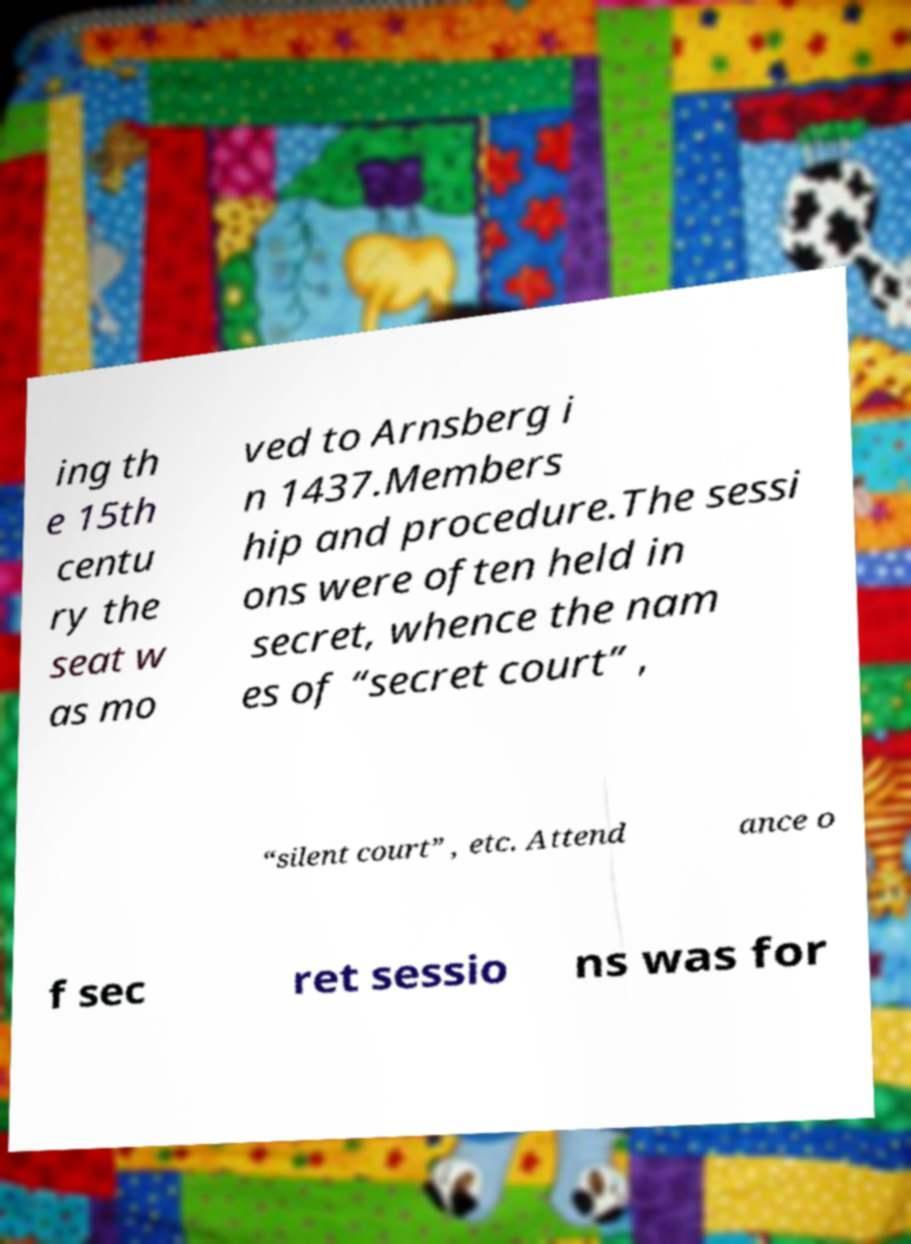Could you extract and type out the text from this image? ing th e 15th centu ry the seat w as mo ved to Arnsberg i n 1437.Members hip and procedure.The sessi ons were often held in secret, whence the nam es of “secret court” , “silent court” , etc. Attend ance o f sec ret sessio ns was for 